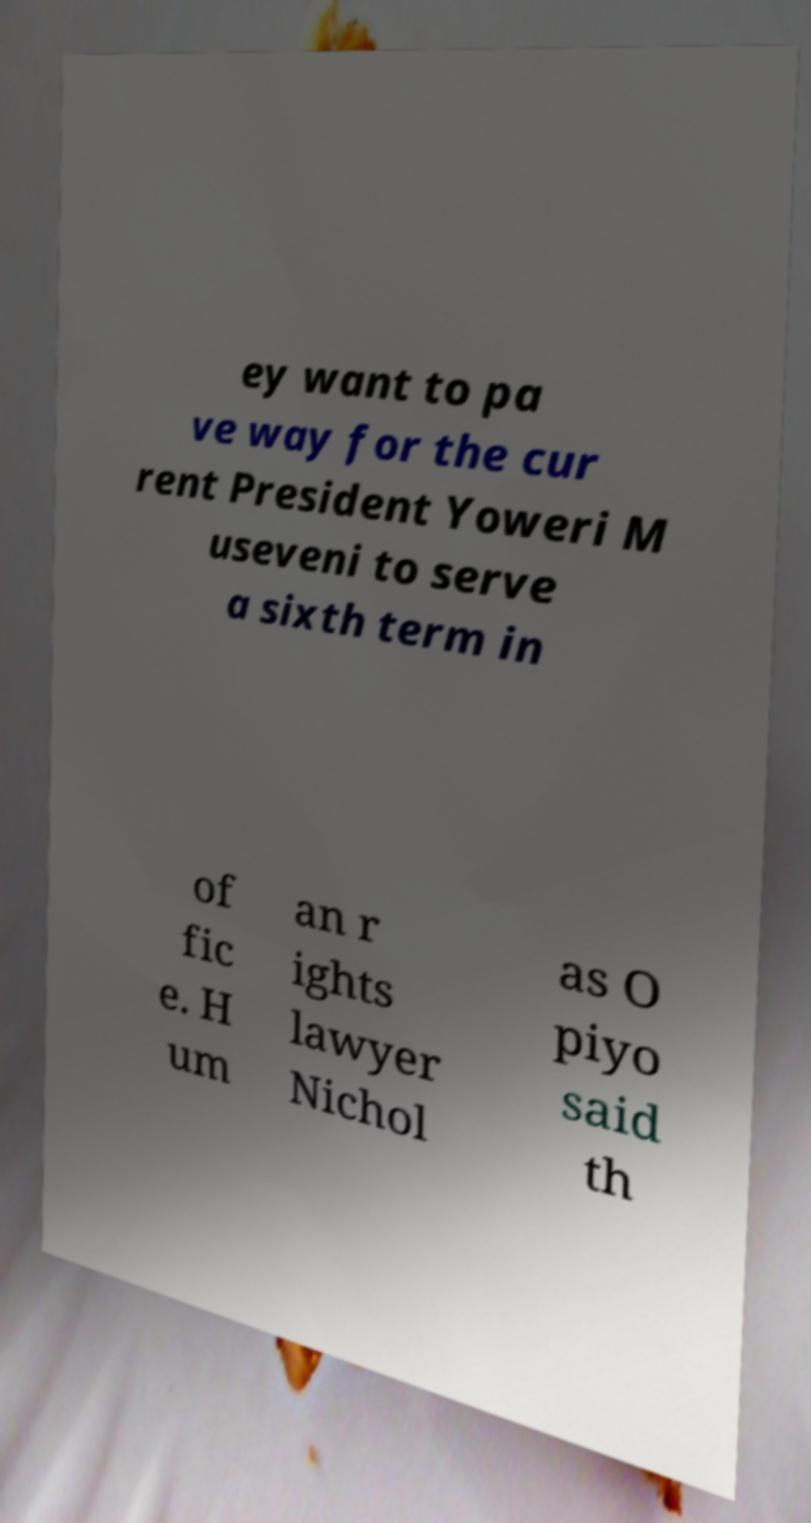Can you accurately transcribe the text from the provided image for me? ey want to pa ve way for the cur rent President Yoweri M useveni to serve a sixth term in of fic e. H um an r ights lawyer Nichol as O piyo said th 